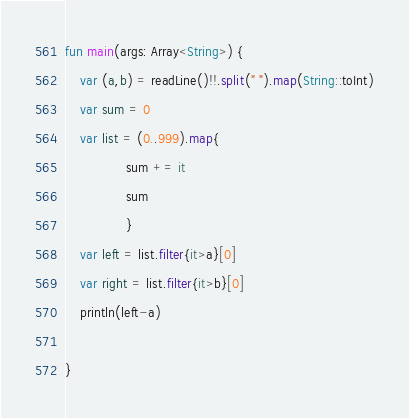<code> <loc_0><loc_0><loc_500><loc_500><_Kotlin_>fun main(args: Array<String>) {
    var (a,b) = readLine()!!.split(" ").map(String::toInt)
    var sum = 0
    var list = (0..999).map{
                sum += it
                sum
                }
    var left = list.filter{it>a}[0]
    var right = list.filter{it>b}[0]
    println(left-a)
    
}
</code> 